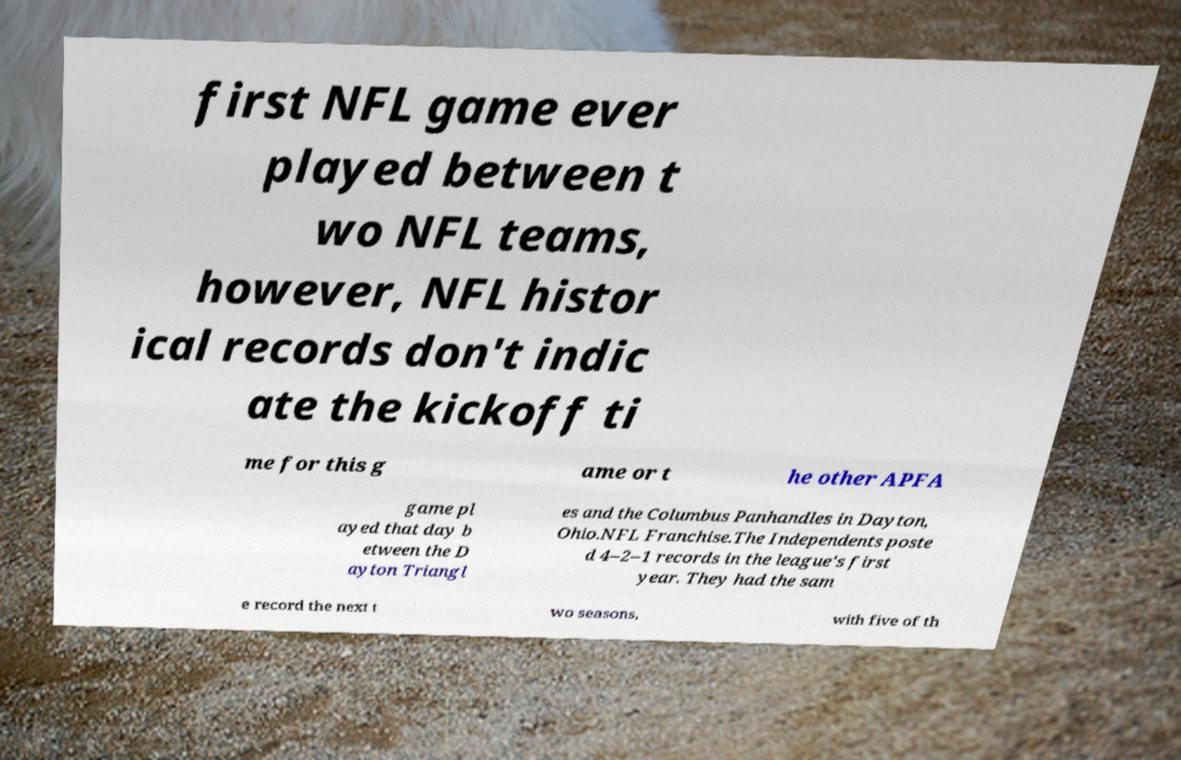Please identify and transcribe the text found in this image. first NFL game ever played between t wo NFL teams, however, NFL histor ical records don't indic ate the kickoff ti me for this g ame or t he other APFA game pl ayed that day b etween the D ayton Triangl es and the Columbus Panhandles in Dayton, Ohio.NFL Franchise.The Independents poste d 4–2–1 records in the league's first year. They had the sam e record the next t wo seasons, with five of th 